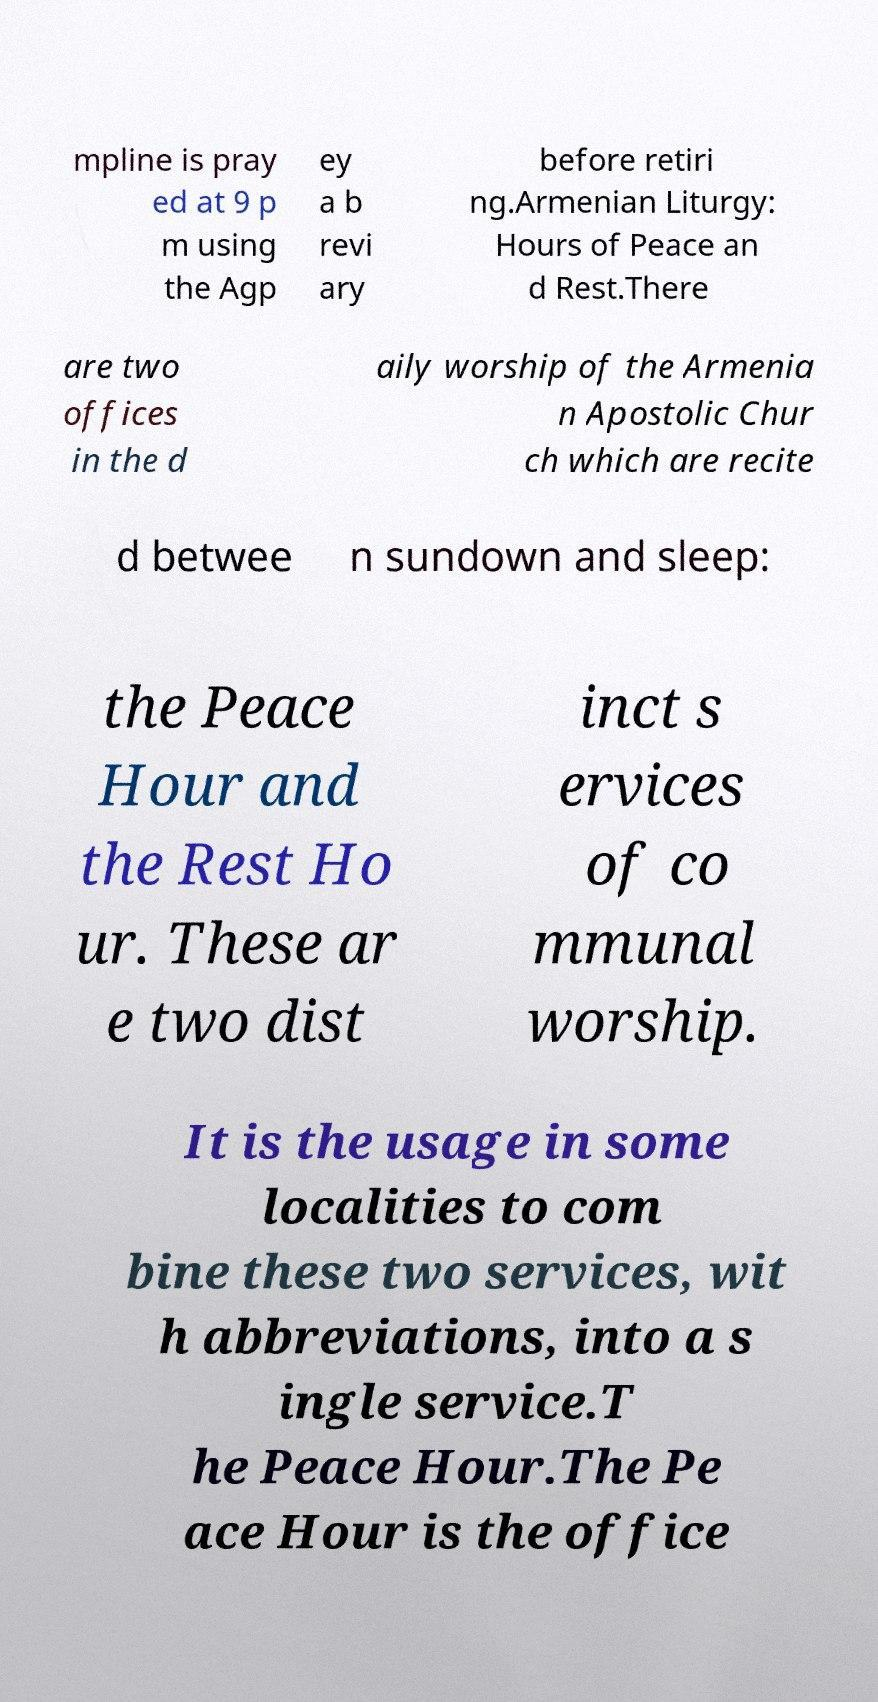For documentation purposes, I need the text within this image transcribed. Could you provide that? mpline is pray ed at 9 p m using the Agp ey a b revi ary before retiri ng.Armenian Liturgy: Hours of Peace an d Rest.There are two offices in the d aily worship of the Armenia n Apostolic Chur ch which are recite d betwee n sundown and sleep: the Peace Hour and the Rest Ho ur. These ar e two dist inct s ervices of co mmunal worship. It is the usage in some localities to com bine these two services, wit h abbreviations, into a s ingle service.T he Peace Hour.The Pe ace Hour is the office 